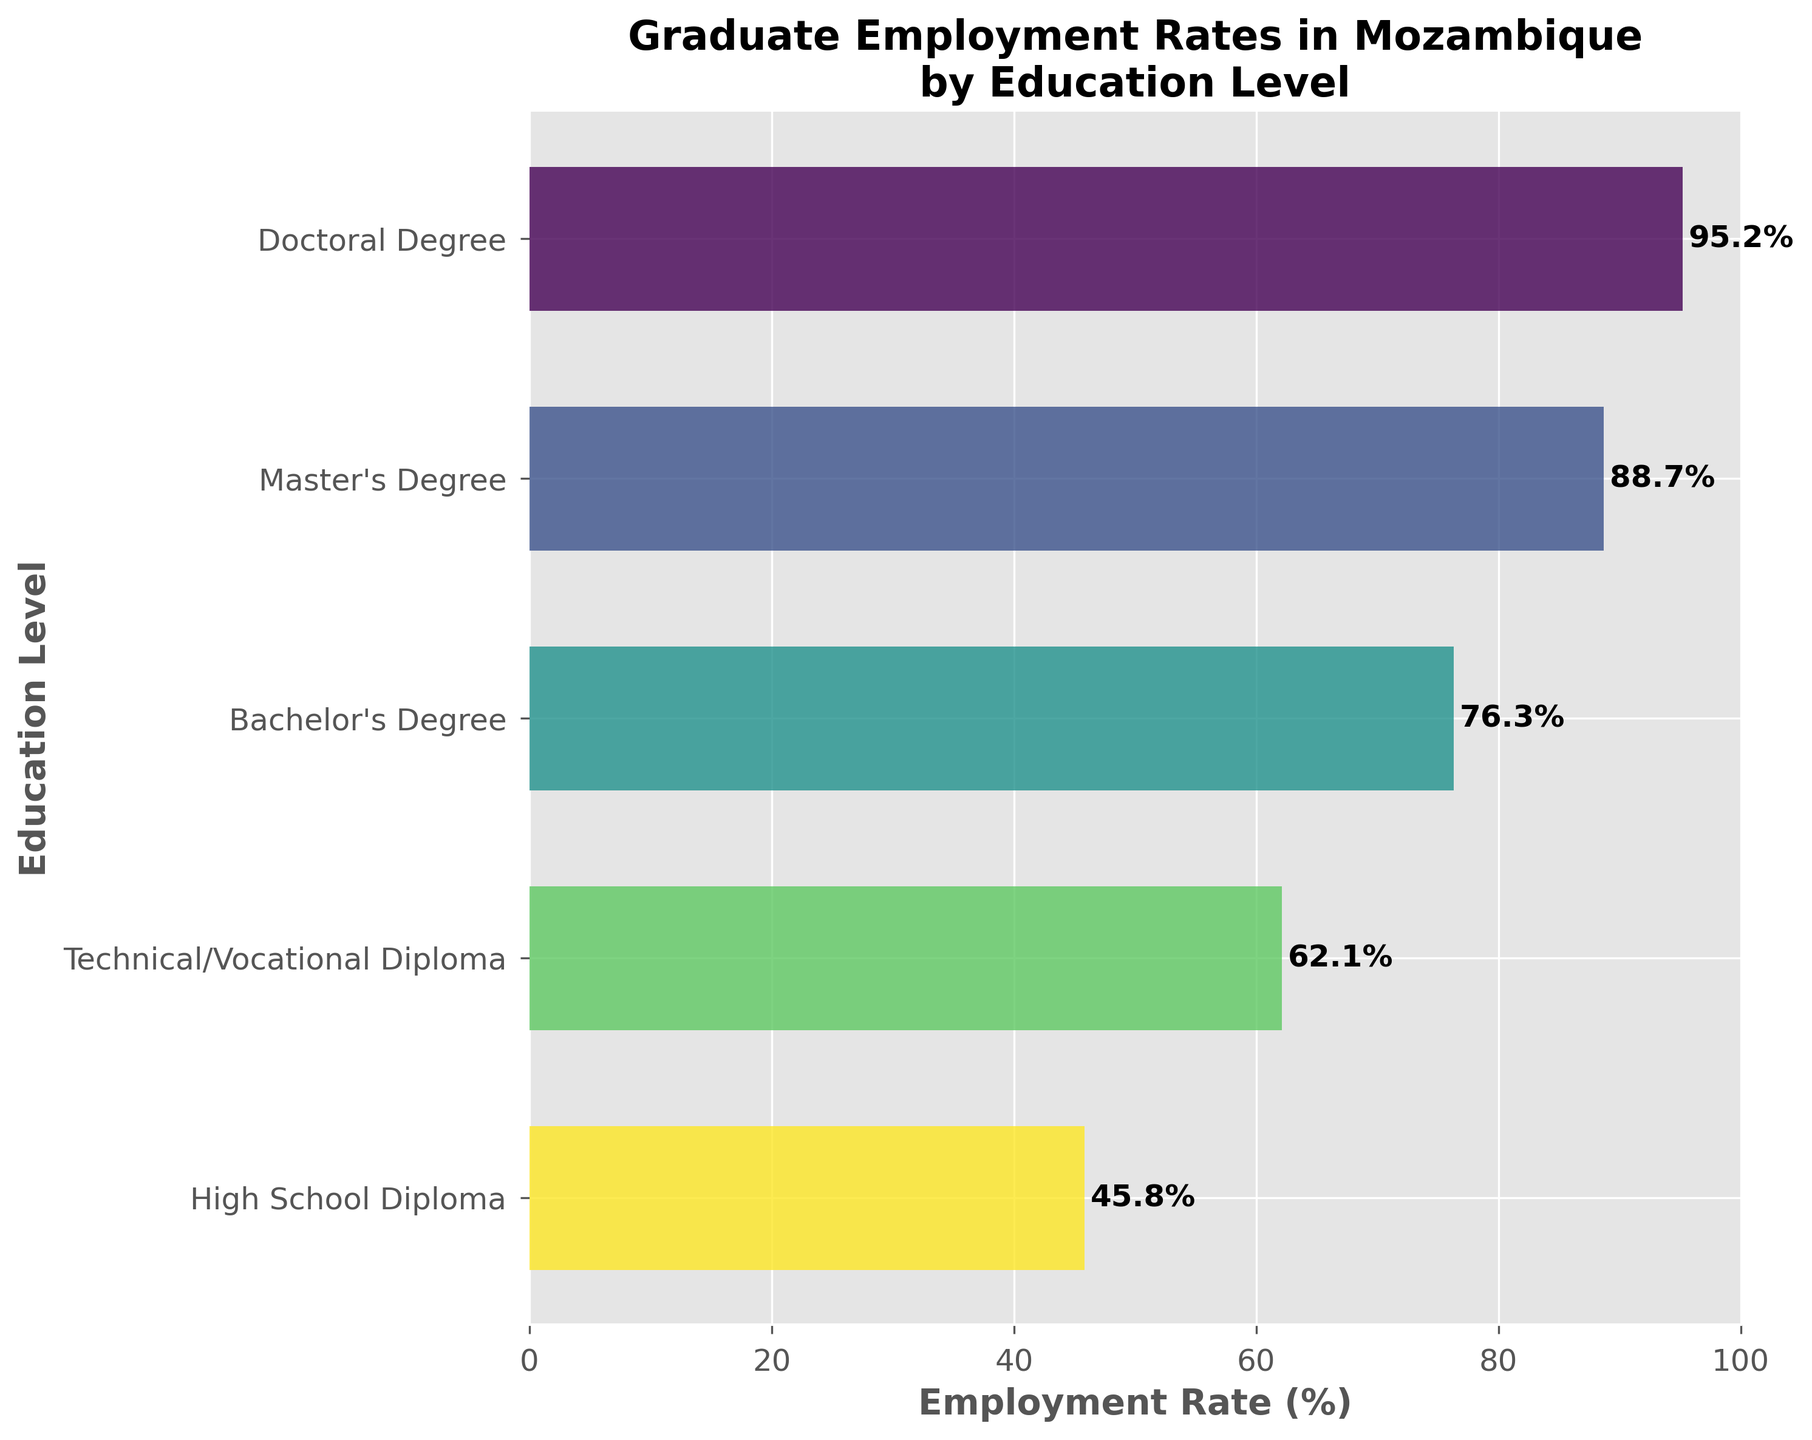What's the employment rate for individuals with a Master's Degree? The bar representing the employment rate for individuals with a Master's Degree has a label. The text near this bar shows "88.7%"
Answer: 88.7% What's the title of the figure? The title is located at the top of the figure, clearly stating the main focus of the plot. The title reads "Graduate Employment Rates in Mozambique by Education Level"
Answer: Graduate Employment Rates in Mozambique by Education Level Which education level has the lowest employment rate? By looking at the heights of the bars from top to bottom, the lowest bar corresponds to the High School Diploma category. The labeled value for this bar shows "45.8%"
Answer: High School Diploma What's the difference in the employment rates between individuals with a Bachelor's Degree and a High School Diploma? The employment rate for Bachelor's Degree is given as 76.3%, and for High School Diploma, it's 45.8%. Subtract 45.8 from 76.3 to find the difference
Answer: 30.5% How does the employment rate for a Technical/Vocational Diploma compare to a Master's Degree? The employment rate for a Technical/Vocational Diploma is 62.1%, while for a Master's Degree, it is 88.7%. 62.1% is less than 88.7%
Answer: Less than What's the average employment rate across all education levels shown? Add up the employment rates for all five education levels and then divide by the number of levels (5). (95.2 + 88.7 + 76.3 + 62.1 + 45.8) / 5 = 368.1 / 5 = 73.62
Answer: 73.62% Which education level shows an employment rate closest to 80%? Check the employment rates provided for each education level and identify the one closest to 80%. Bachelor's Degree is 76.3%, which is the closest to 80%
Answer: Bachelor's Degree What's the employment rate for individuals with a Doctoral Degree and how does it compare to those with a Master's Degree? The employment rate for Doctoral Degree is 95.2%, and for a Master's Degree, it's 88.7%. Hence, 95.2% is higher than 88.7%
Answer: Higher What's the color gradient used in the bars? The bars are colored using shades that transition from one end of the color spectrum to another, based on the employment rates. This gradient visually ranks the education levels from lowest to highest
Answer: Gradient based on values 